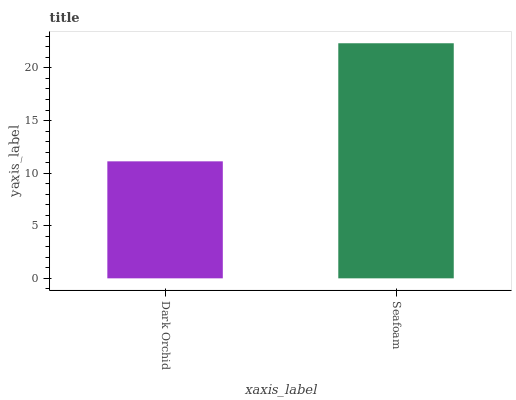Is Seafoam the minimum?
Answer yes or no. No. Is Seafoam greater than Dark Orchid?
Answer yes or no. Yes. Is Dark Orchid less than Seafoam?
Answer yes or no. Yes. Is Dark Orchid greater than Seafoam?
Answer yes or no. No. Is Seafoam less than Dark Orchid?
Answer yes or no. No. Is Seafoam the high median?
Answer yes or no. Yes. Is Dark Orchid the low median?
Answer yes or no. Yes. Is Dark Orchid the high median?
Answer yes or no. No. Is Seafoam the low median?
Answer yes or no. No. 